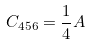Convert formula to latex. <formula><loc_0><loc_0><loc_500><loc_500>C _ { 4 5 6 } = \frac { 1 } { 4 } A</formula> 